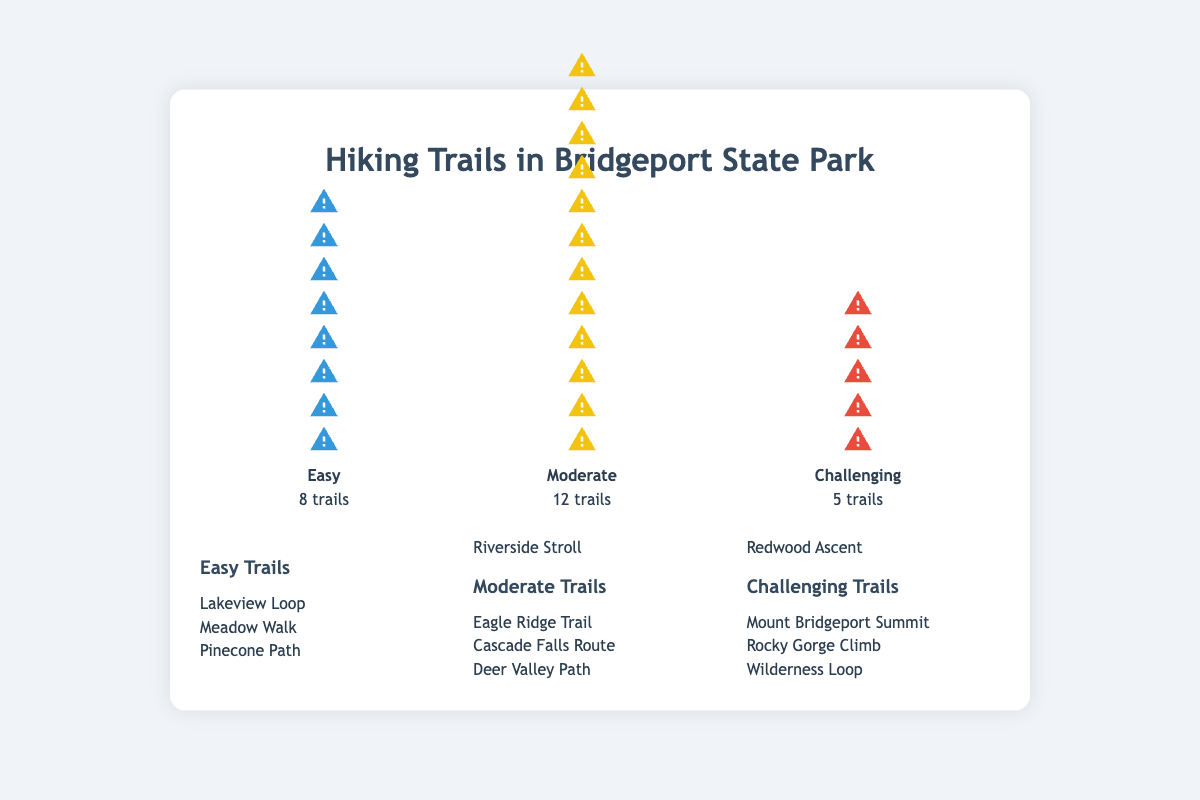What is the title of the plot? The title of the plot is placed at the top and provides a clear summary of what the figure represents.
Answer: Hiking Trails in Bridgeport State Park How many easy trails are there in Bridgeport State Park? The number of easy trails can be seen above the "Easy" label in the Isotype Plot.
Answer: 8 trails Which difficulty category has the most trails? By comparing the count labels below each difficulty category, we can see which has the highest number. Moderate has 12, which is the highest.
Answer: Moderate How many more moderate trails are there compared to challenging trails? Subtract the number of challenging trails (5) from the number of moderate trails (12).
Answer: 7 more trails What is the combined total number of hiking trails across all difficulty levels? Add the trails in each category: 8 (Easy) + 12 (Moderate) + 5 (Challenging).
Answer: 25 trails Name two easy trails in Bridgeport State Park? The names of the easy trails are listed under the "Easy Trails" section. Any two trails can be chosen.
Answer: Lakeview Loop, Meadow Walk Are there more easy trails or challenging trails? Compare the numbers below the "Easy" and "Challenging" labels. Easy has 8, and challenging has 5 trails.
Answer: Easy What percentage of hiking trails are categorized as moderate? Divide the number of moderate trails (12) by the total number of trails (25) and multiply by 100. Detailed calculation: (12 / 25) * 100 = 48%.
Answer: 48% Which category has fewer trails: Easy or Challenging? Compare the count labels beneath "Easy" and "Challenging." Easy has 8 trails, and challenging has 5.
Answer: Challenging List all the challenging trails. The names of the challenging trails are provided under the "Challenging Trails" section.
Answer: Mount Bridgeport Summit, Rocky Gorge Climb, Wilderness Loop 